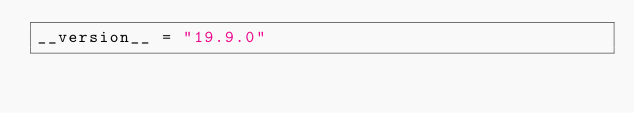<code> <loc_0><loc_0><loc_500><loc_500><_Python_>__version__ = "19.9.0"
</code> 